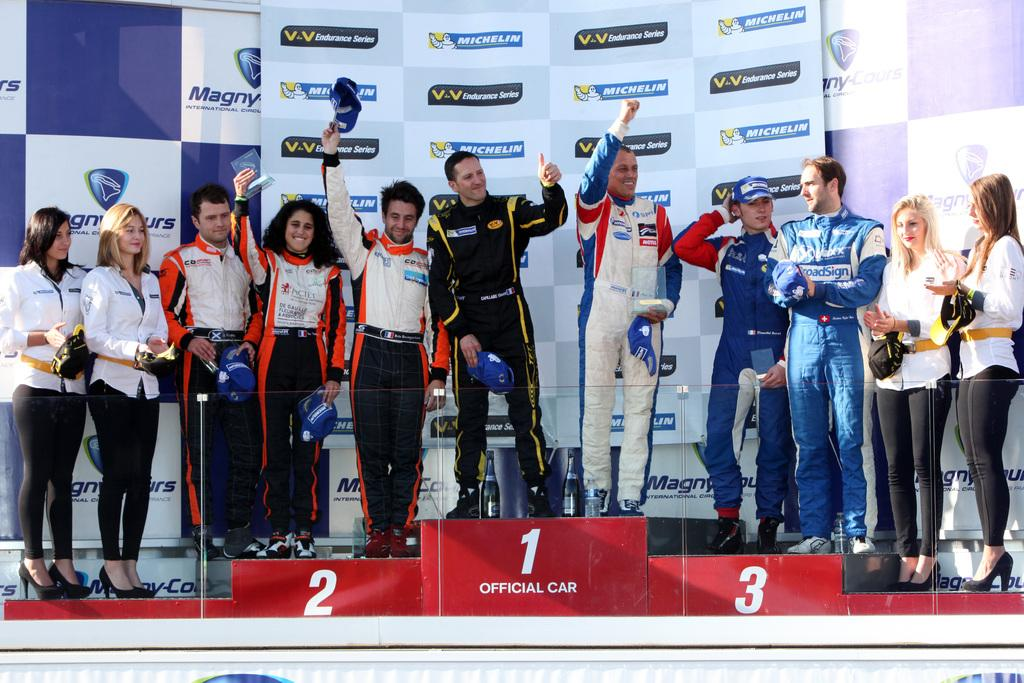<image>
Give a short and clear explanation of the subsequent image. Racecar drivers win race sponsored by Michelin and Valvoline. 